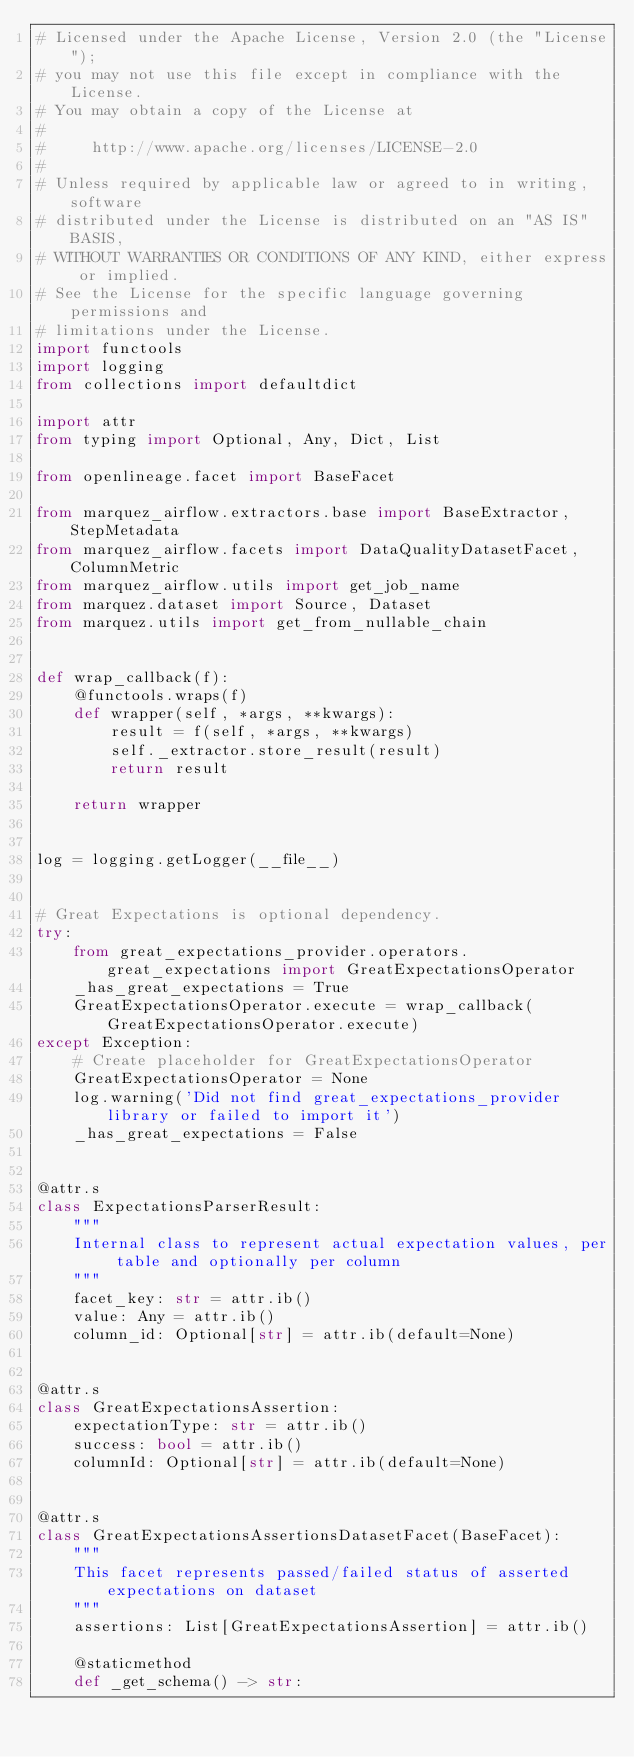<code> <loc_0><loc_0><loc_500><loc_500><_Python_># Licensed under the Apache License, Version 2.0 (the "License");
# you may not use this file except in compliance with the License.
# You may obtain a copy of the License at
#
#     http://www.apache.org/licenses/LICENSE-2.0
#
# Unless required by applicable law or agreed to in writing, software
# distributed under the License is distributed on an "AS IS" BASIS,
# WITHOUT WARRANTIES OR CONDITIONS OF ANY KIND, either express or implied.
# See the License for the specific language governing permissions and
# limitations under the License.
import functools
import logging
from collections import defaultdict

import attr
from typing import Optional, Any, Dict, List

from openlineage.facet import BaseFacet

from marquez_airflow.extractors.base import BaseExtractor, StepMetadata
from marquez_airflow.facets import DataQualityDatasetFacet, ColumnMetric
from marquez_airflow.utils import get_job_name
from marquez.dataset import Source, Dataset
from marquez.utils import get_from_nullable_chain


def wrap_callback(f):
    @functools.wraps(f)
    def wrapper(self, *args, **kwargs):
        result = f(self, *args, **kwargs)
        self._extractor.store_result(result)
        return result

    return wrapper


log = logging.getLogger(__file__)


# Great Expectations is optional dependency.
try:
    from great_expectations_provider.operators.great_expectations import GreatExpectationsOperator
    _has_great_expectations = True
    GreatExpectationsOperator.execute = wrap_callback(GreatExpectationsOperator.execute)
except Exception:
    # Create placeholder for GreatExpectationsOperator
    GreatExpectationsOperator = None
    log.warning('Did not find great_expectations_provider library or failed to import it')
    _has_great_expectations = False


@attr.s
class ExpectationsParserResult:
    """
    Internal class to represent actual expectation values, per table and optionally per column
    """
    facet_key: str = attr.ib()
    value: Any = attr.ib()
    column_id: Optional[str] = attr.ib(default=None)


@attr.s
class GreatExpectationsAssertion:
    expectationType: str = attr.ib()
    success: bool = attr.ib()
    columnId: Optional[str] = attr.ib(default=None)


@attr.s
class GreatExpectationsAssertionsDatasetFacet(BaseFacet):
    """
    This facet represents passed/failed status of asserted expectations on dataset
    """
    assertions: List[GreatExpectationsAssertion] = attr.ib()

    @staticmethod
    def _get_schema() -> str:</code> 